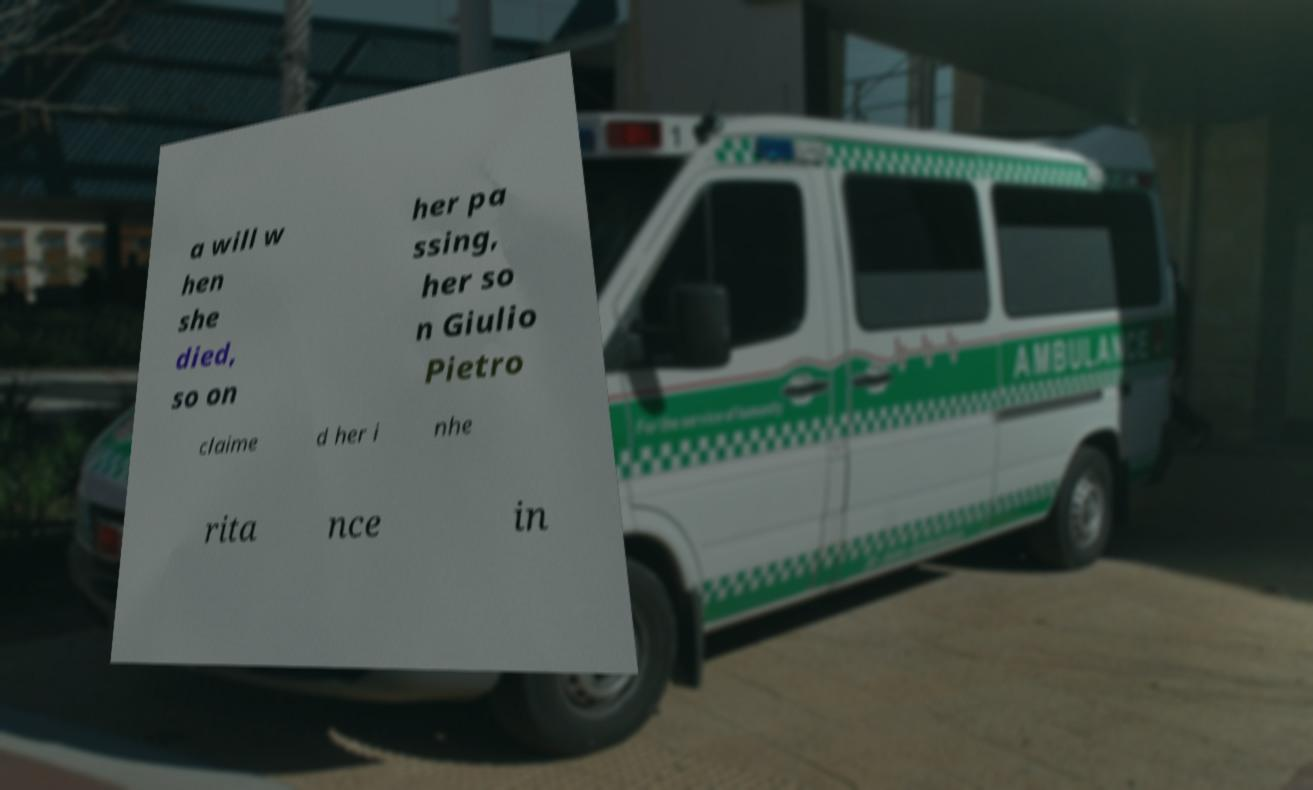Please identify and transcribe the text found in this image. a will w hen she died, so on her pa ssing, her so n Giulio Pietro claime d her i nhe rita nce in 